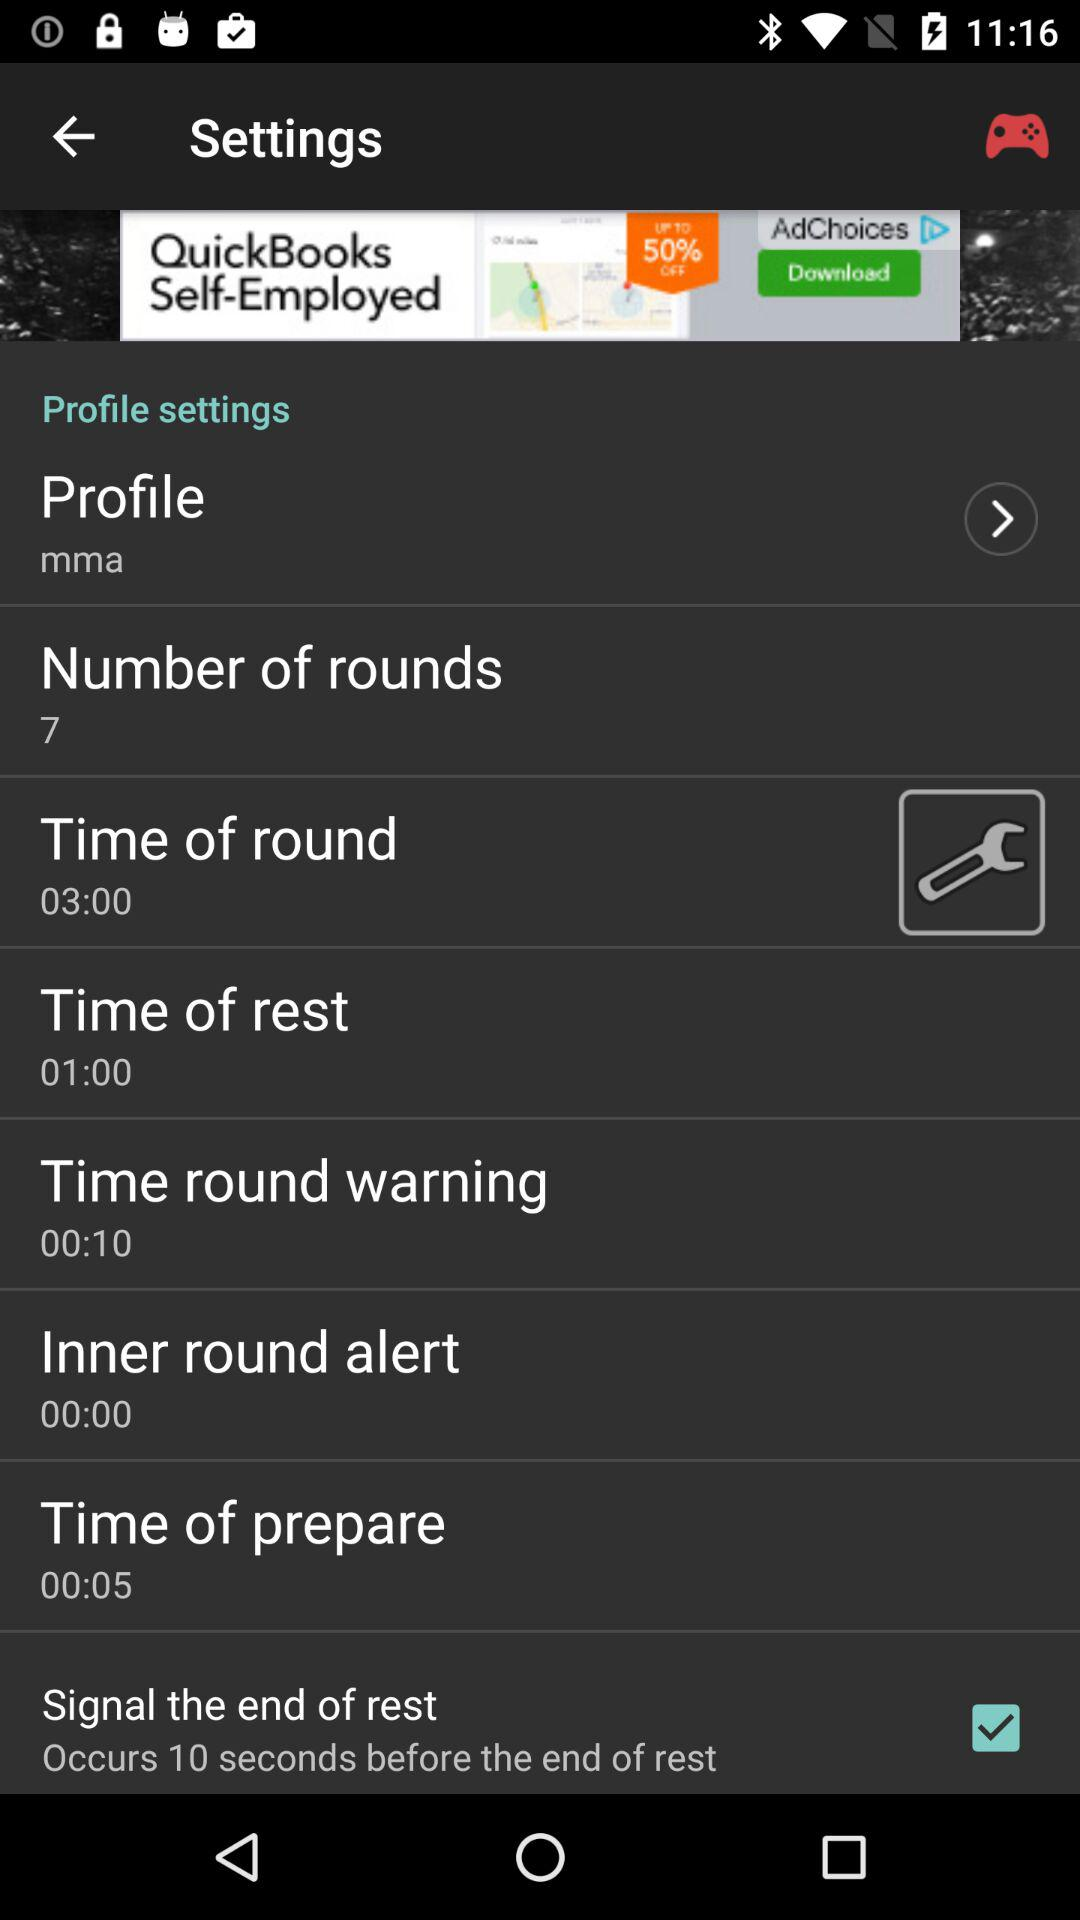What option is selected? The selected option is "Signal the end of rest". 